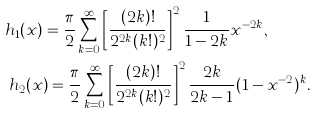<formula> <loc_0><loc_0><loc_500><loc_500>h _ { 1 } ( x ) & = \frac { \pi } { 2 } \sum _ { k = 0 } ^ { \infty } \left [ \frac { ( 2 k ) ! } { 2 ^ { 2 k } ( k ! ) ^ { 2 } } \right ] ^ { 2 } \frac { 1 } { 1 - 2 k } x ^ { - 2 k } , \\ h _ { 2 } ( x & ) = \frac { \pi } { 2 } \sum _ { k = 0 } ^ { \infty } \left [ \frac { ( 2 k ) ! } { 2 ^ { 2 k } ( k ! ) ^ { 2 } } \right ] ^ { 2 } \frac { 2 k } { 2 k - 1 } ( 1 - x ^ { - 2 } ) ^ { k } .</formula> 